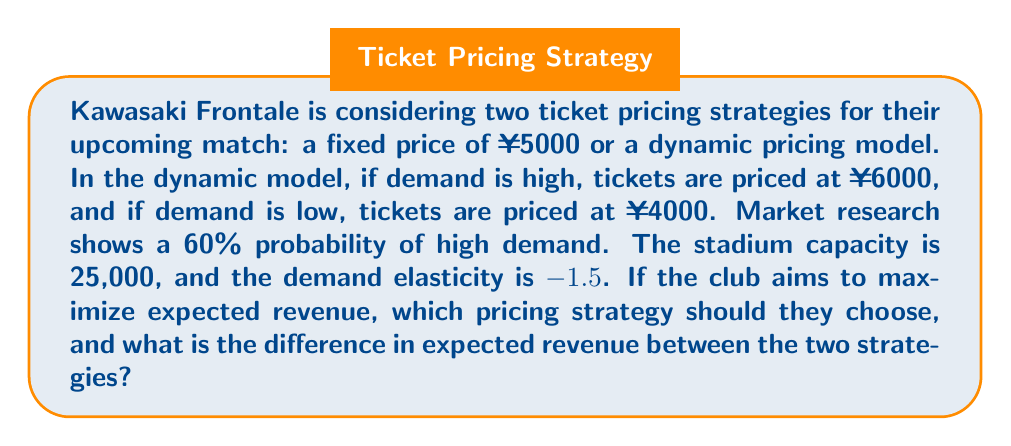Can you answer this question? Let's approach this step-by-step:

1) First, let's calculate the expected revenue for the fixed price strategy:
   Revenue = Price × Quantity
   At ¥5000, with 25,000 capacity: $$R_f = 5000 \times 25000 = 125,000,000$$ yen

2) For the dynamic pricing strategy, we need to consider both scenarios:
   High demand (60% probability): $$R_h = 6000 \times Q_h$$
   Low demand (40% probability): $$R_l = 4000 \times Q_l$$

3) To find $Q_h$ and $Q_l$, we use the concept of price elasticity of demand:
   $$E = \frac{\%\Delta Q}{\%\Delta P} = -1.5$$

4) For high demand:
   $$-1.5 = \frac{(Q_h - 25000)/25000}{(6000 - 5000)/5000}$$
   Solving this: $$Q_h \approx 22,500$$

5) For low demand:
   $$-1.5 = \frac{(Q_l - 25000)/25000}{(4000 - 5000)/5000}$$
   Solving this: $$Q_l \approx 28,750$$ (capped at 25,000 due to stadium capacity)

6) Now we can calculate the expected revenue for the dynamic strategy:
   $$R_d = 0.6 \times (6000 \times 22500) + 0.4 \times (4000 \times 25000)$$
   $$R_d = 81,000,000 + 40,000,000 = 121,000,000$$ yen

7) The difference in expected revenue:
   $$125,000,000 - 121,000,000 = 4,000,000$$ yen

Therefore, the fixed price strategy yields higher expected revenue by 4 million yen.
Answer: Fixed price strategy; ¥4,000,000 higher 